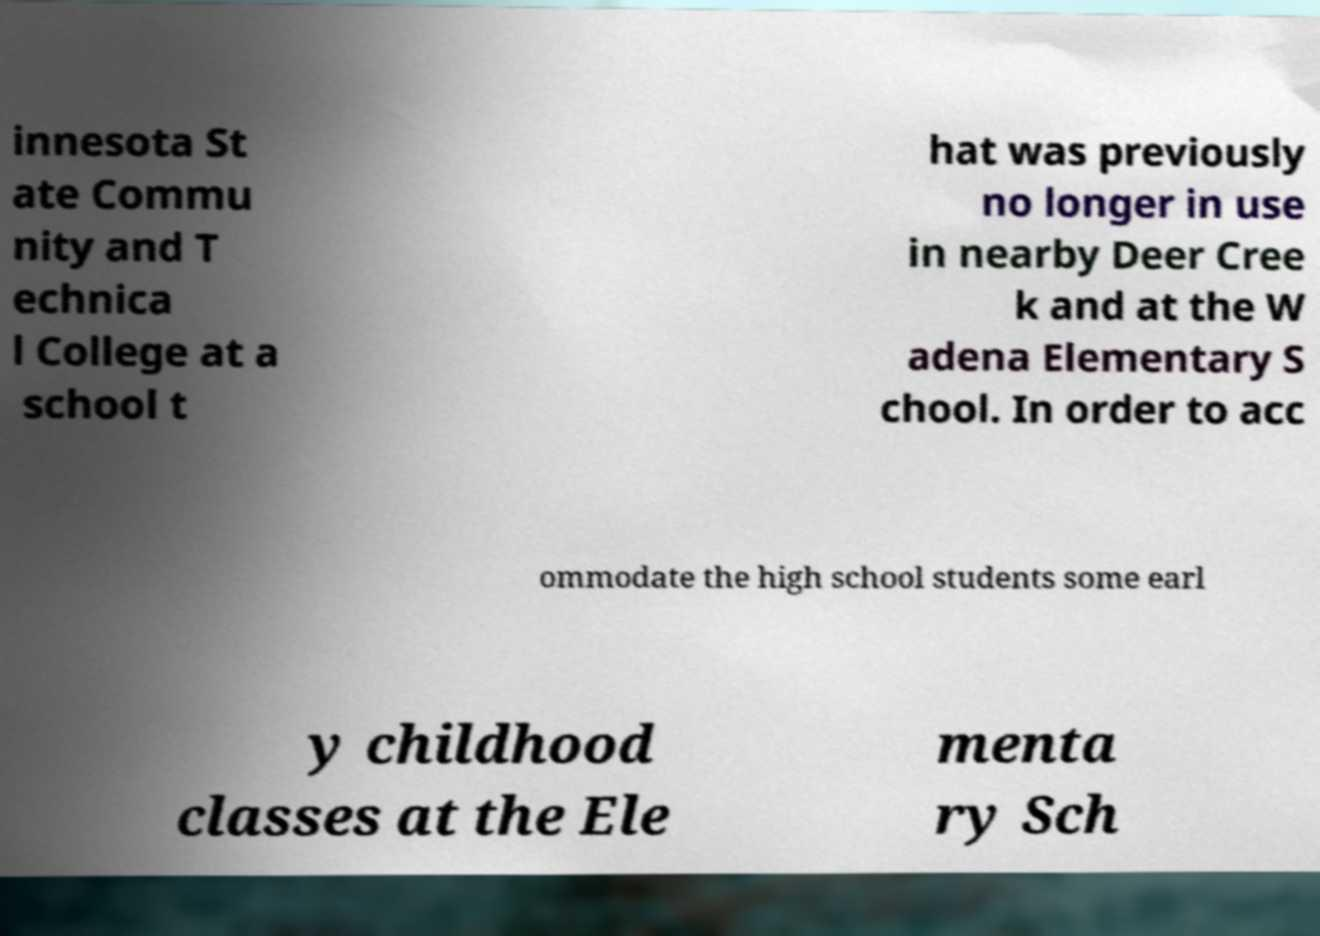There's text embedded in this image that I need extracted. Can you transcribe it verbatim? innesota St ate Commu nity and T echnica l College at a school t hat was previously no longer in use in nearby Deer Cree k and at the W adena Elementary S chool. In order to acc ommodate the high school students some earl y childhood classes at the Ele menta ry Sch 